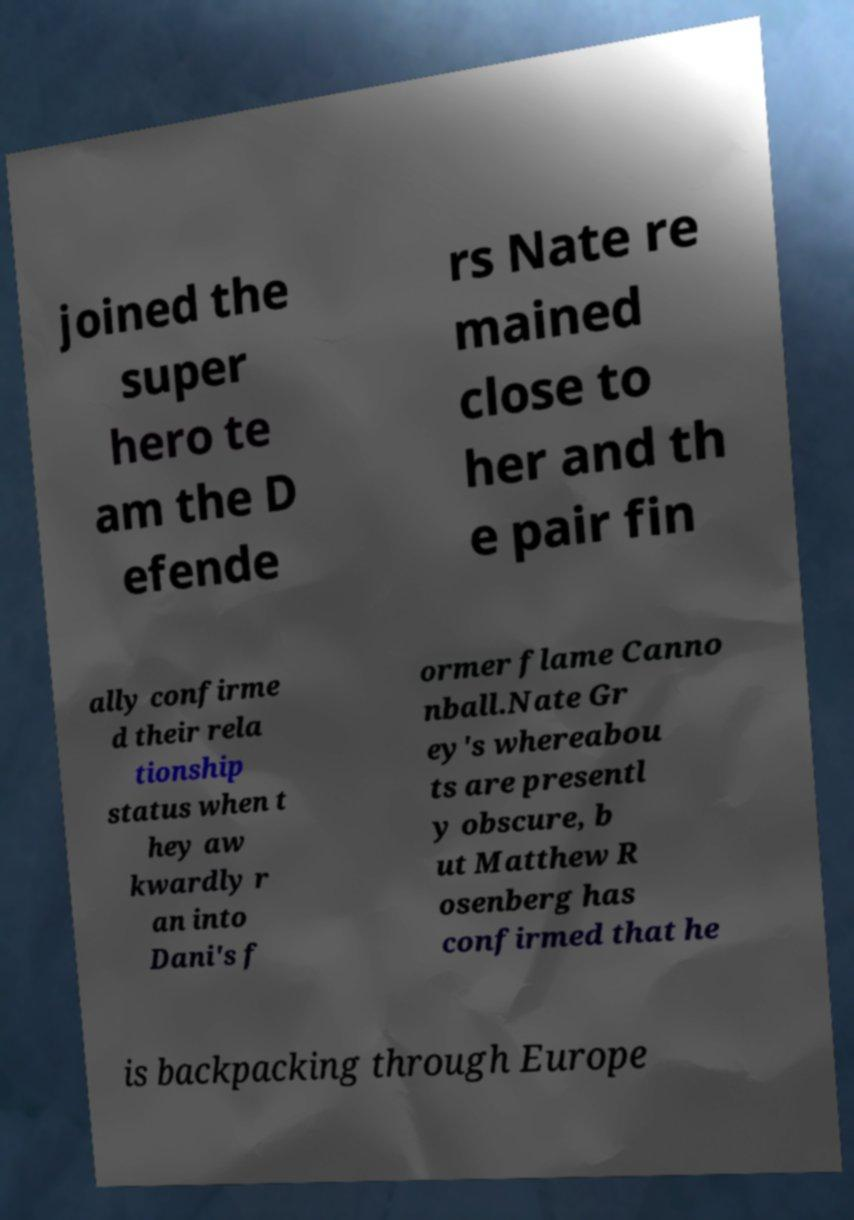Can you accurately transcribe the text from the provided image for me? joined the super hero te am the D efende rs Nate re mained close to her and th e pair fin ally confirme d their rela tionship status when t hey aw kwardly r an into Dani's f ormer flame Canno nball.Nate Gr ey's whereabou ts are presentl y obscure, b ut Matthew R osenberg has confirmed that he is backpacking through Europe 